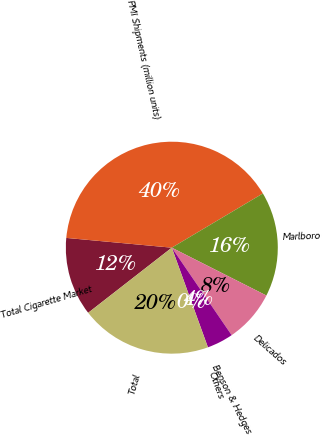Convert chart to OTSL. <chart><loc_0><loc_0><loc_500><loc_500><pie_chart><fcel>Total Cigarette Market<fcel>PMI Shipments (million units)<fcel>Marlboro<fcel>Delicados<fcel>Benson & Hedges<fcel>Others<fcel>Total<nl><fcel>12.0%<fcel>39.99%<fcel>16.0%<fcel>8.0%<fcel>4.01%<fcel>0.01%<fcel>20.0%<nl></chart> 